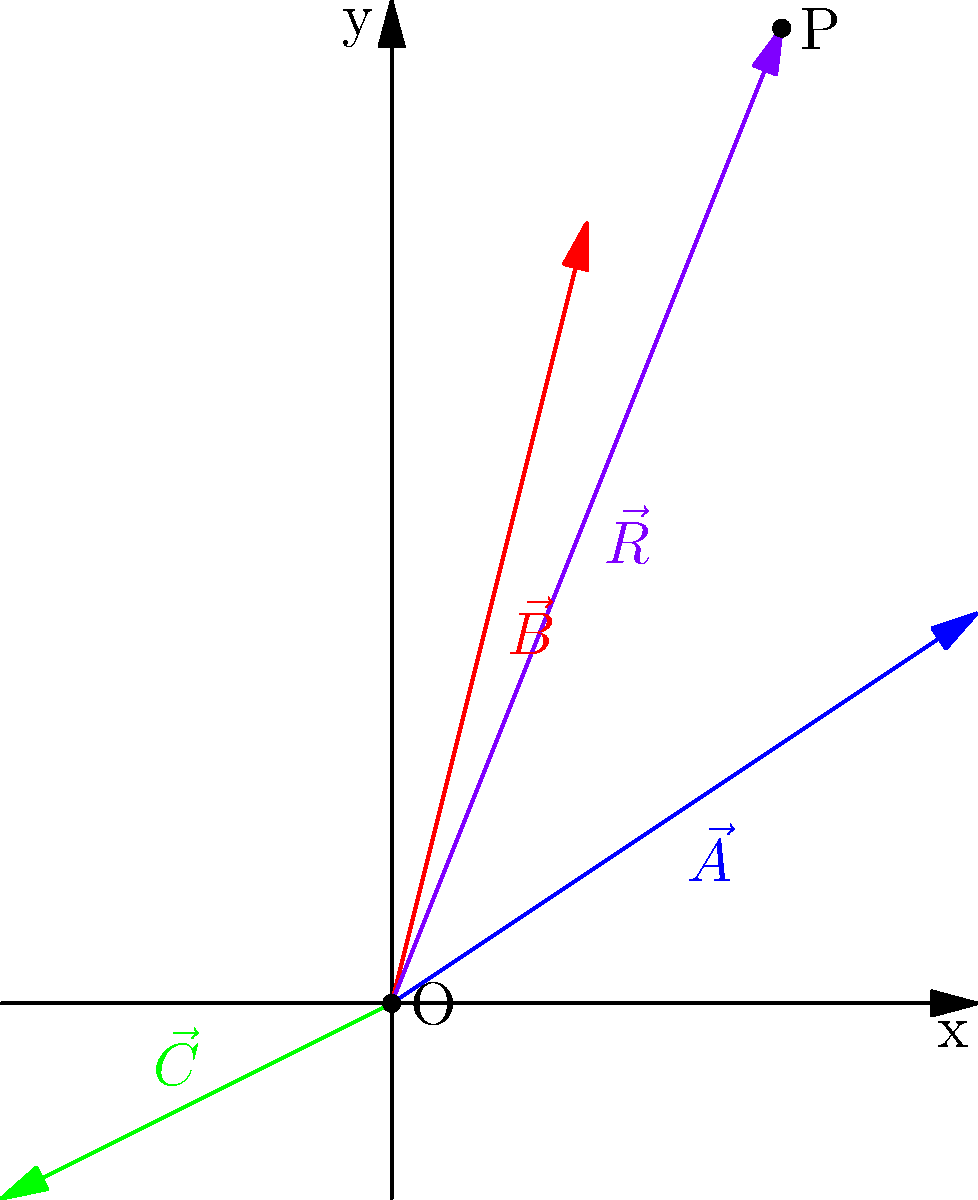In a complex radiation therapy plan, three radiation fields are represented by vectors $\vec{A} = (3,2)$, $\vec{B} = (1,4)$, and $\vec{C} = (-2,-1)$. The resultant vector $\vec{R}$ represents the area of maximum overlap. Calculate the coordinates of point P, which represents the center of the overlap region. To find the coordinates of point P, we need to calculate the resultant vector $\vec{R}$ by adding the three given vectors:

1) First, let's add vectors $\vec{A}$ and $\vec{B}$:
   $\vec{A} + \vec{B} = (3,2) + (1,4) = (4,6)$

2) Now, add vector $\vec{C}$ to the result:
   $(4,6) + (-2,-1) = (2,5)$

3) Therefore, the resultant vector $\vec{R}$ is:
   $\vec{R} = \vec{A} + \vec{B} + \vec{C} = (2,5)$

4) The coordinates of point P are the same as the components of vector $\vec{R}$.

Thus, the center of the overlap region (point P) is located at coordinates (2,5).
Answer: (2,5) 